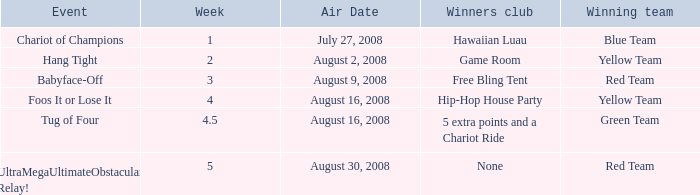Which Winners club has an Event of hang tight? Game Room. 